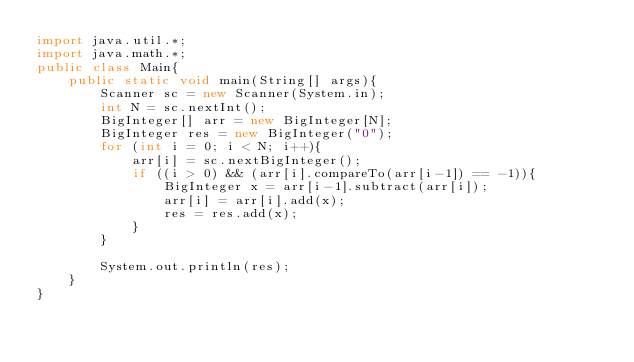Convert code to text. <code><loc_0><loc_0><loc_500><loc_500><_Java_>import java.util.*;
import java.math.*;
public class Main{
	public static void main(String[] args){
    	Scanner sc = new Scanner(System.in);
      	int N = sc.nextInt();
      	BigInteger[] arr = new BigInteger[N];
      	BigInteger res = new BigInteger("0");
      	for (int i = 0; i < N; i++){
        	arr[i] = sc.nextBigInteger();
          	if ((i > 0) && (arr[i].compareTo(arr[i-1]) == -1)){
            	BigInteger x = arr[i-1].subtract(arr[i]);
              	arr[i] = arr[i].add(x);
            	res = res.add(x);
            }
        }
      	
      	System.out.println(res);
    }
}</code> 